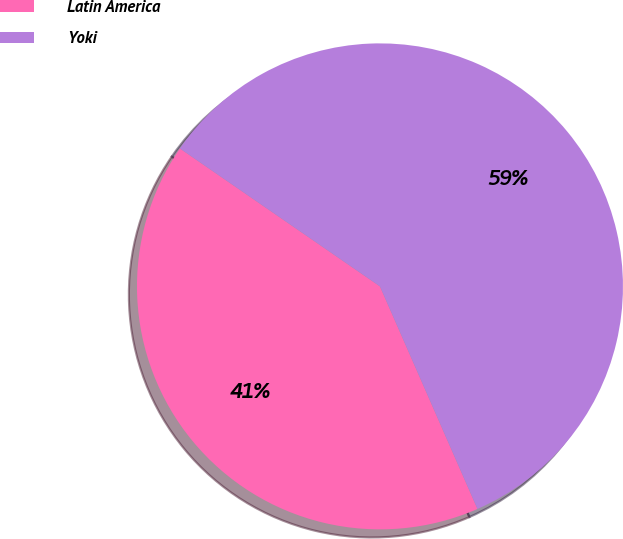Convert chart to OTSL. <chart><loc_0><loc_0><loc_500><loc_500><pie_chart><fcel>Latin America<fcel>Yoki<nl><fcel>41.18%<fcel>58.82%<nl></chart> 